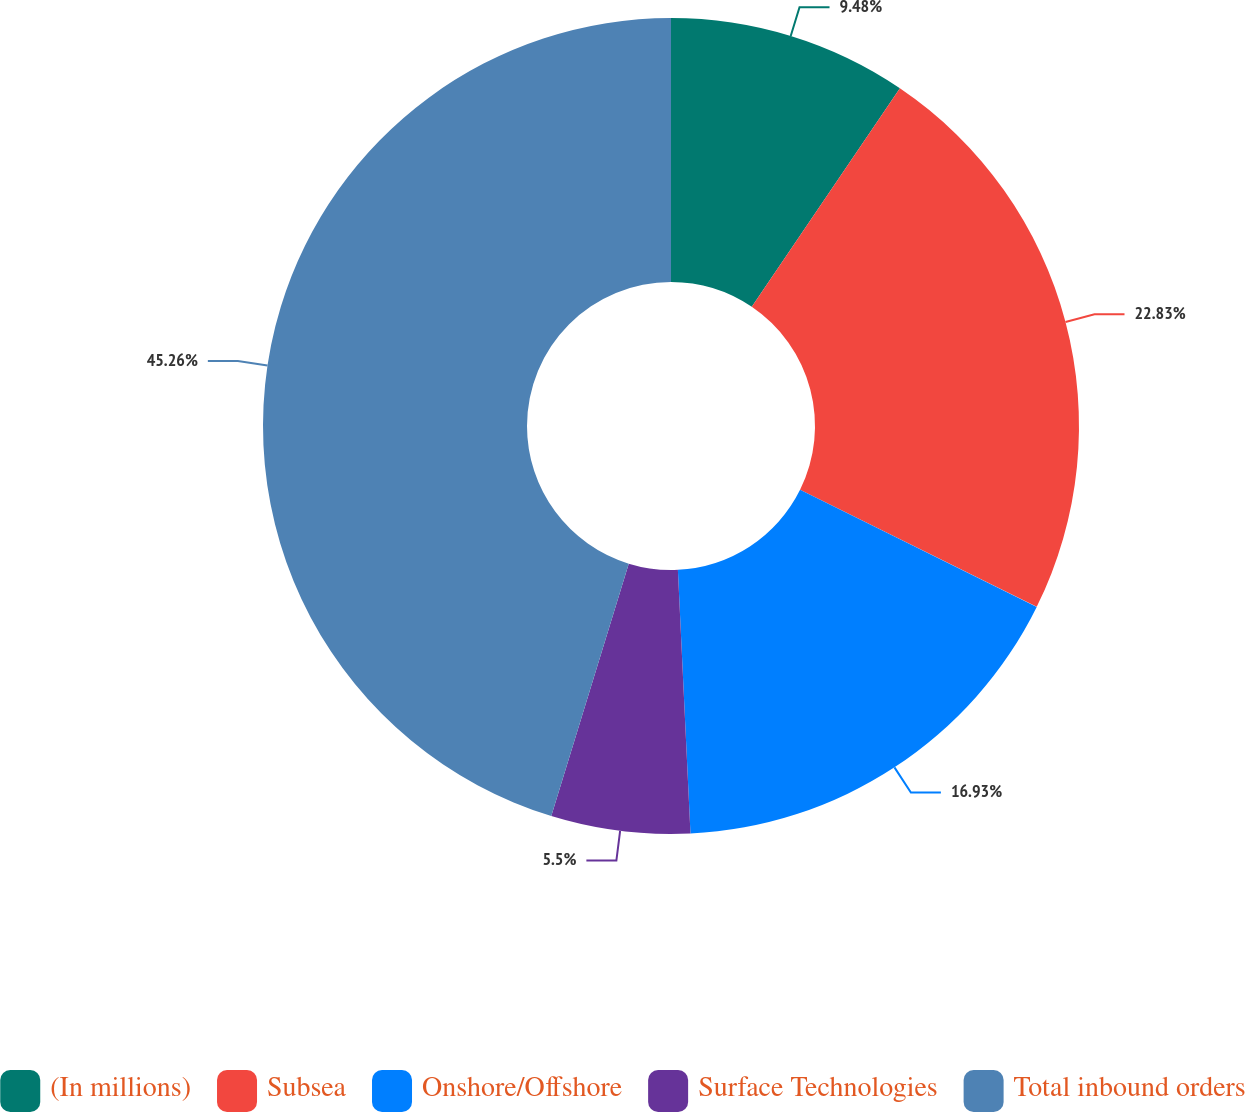Convert chart to OTSL. <chart><loc_0><loc_0><loc_500><loc_500><pie_chart><fcel>(In millions)<fcel>Subsea<fcel>Onshore/Offshore<fcel>Surface Technologies<fcel>Total inbound orders<nl><fcel>9.48%<fcel>22.83%<fcel>16.93%<fcel>5.5%<fcel>45.26%<nl></chart> 